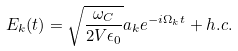<formula> <loc_0><loc_0><loc_500><loc_500>E _ { k } ( t ) = \sqrt { \frac { \omega _ { C } } { 2 V \epsilon _ { 0 } } } a _ { k } e ^ { - i \Omega _ { k } t } + h . c .</formula> 